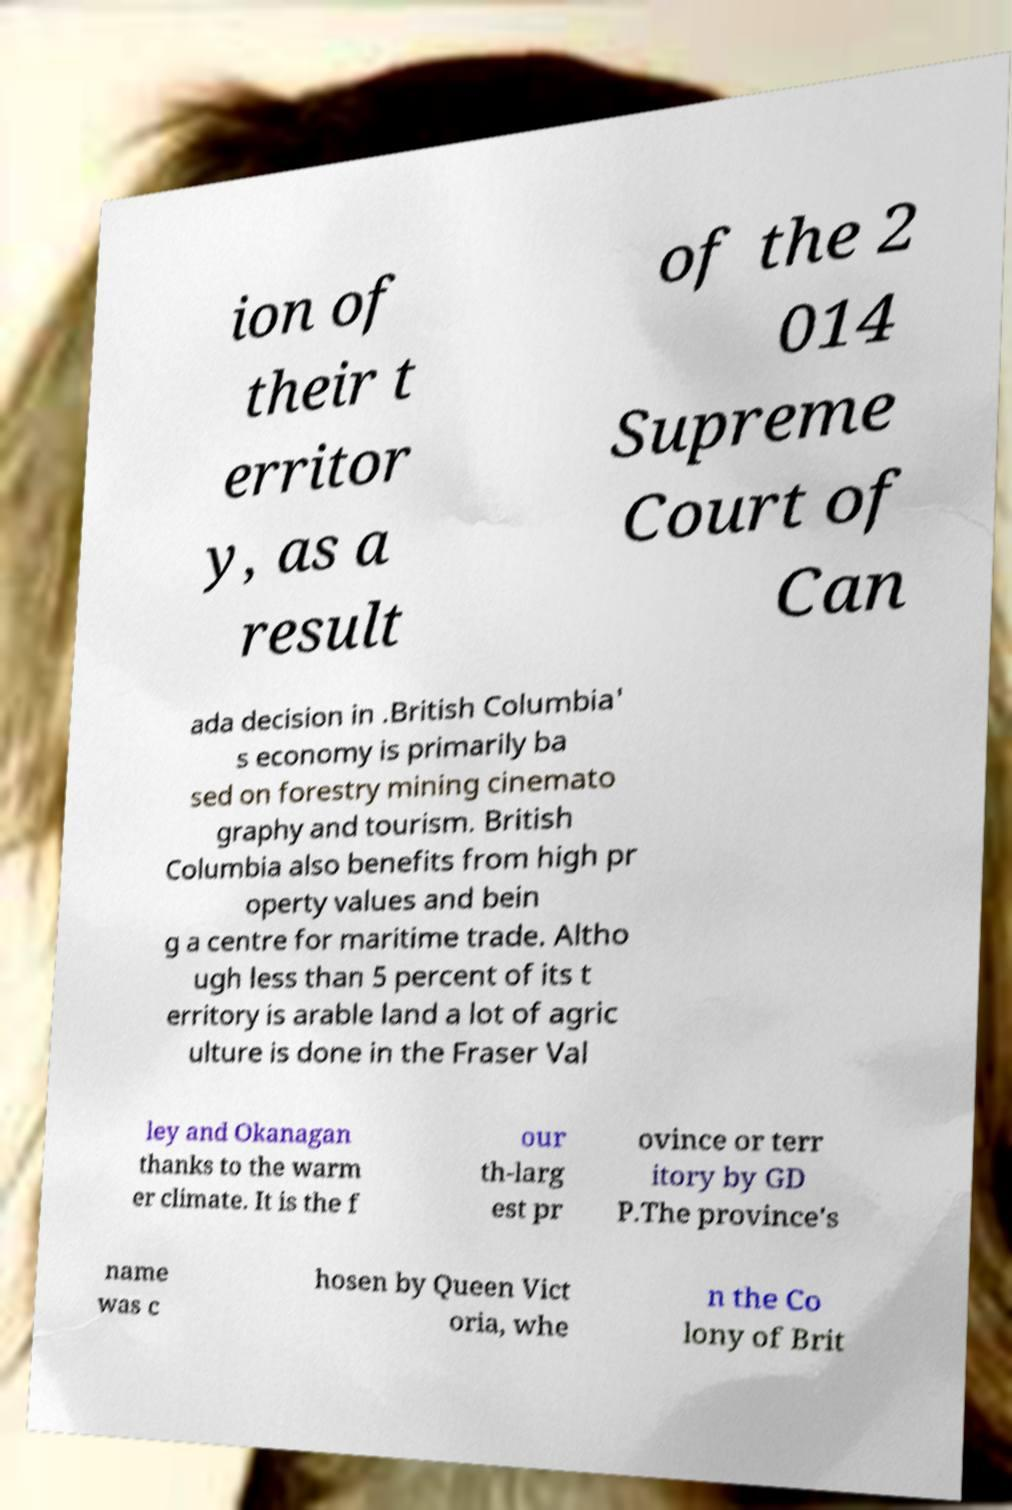Can you accurately transcribe the text from the provided image for me? ion of their t erritor y, as a result of the 2 014 Supreme Court of Can ada decision in .British Columbia' s economy is primarily ba sed on forestry mining cinemato graphy and tourism. British Columbia also benefits from high pr operty values and bein g a centre for maritime trade. Altho ugh less than 5 percent of its t erritory is arable land a lot of agric ulture is done in the Fraser Val ley and Okanagan thanks to the warm er climate. It is the f our th-larg est pr ovince or terr itory by GD P.The province's name was c hosen by Queen Vict oria, whe n the Co lony of Brit 